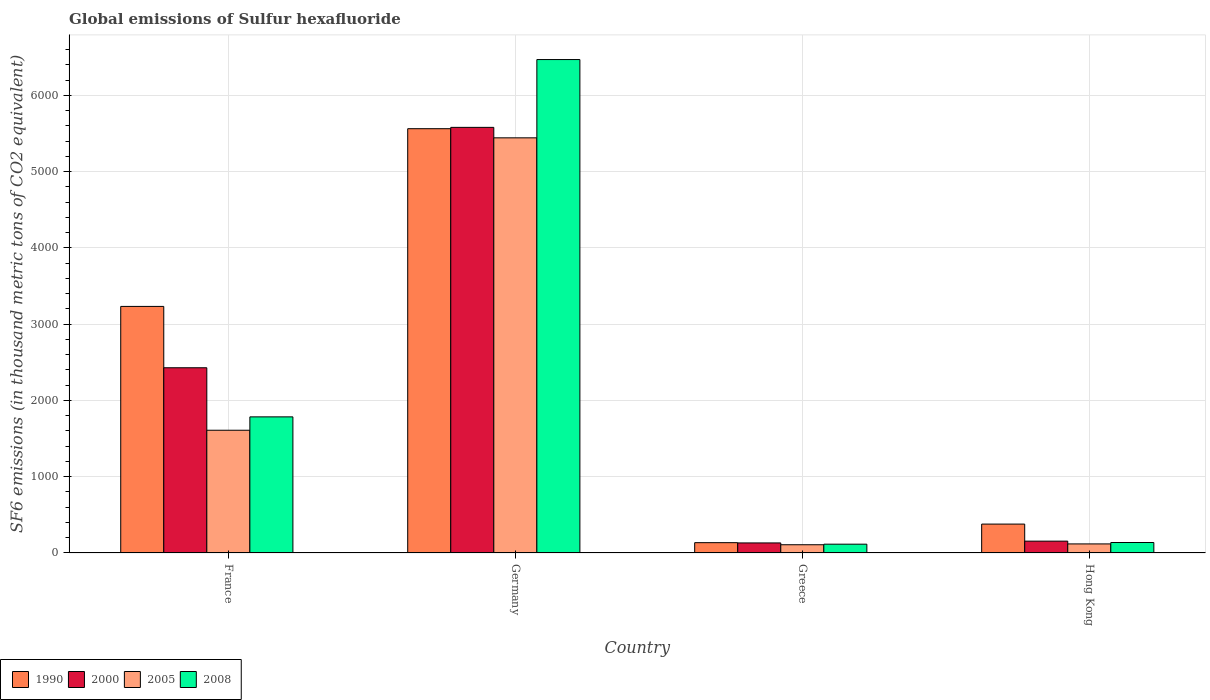How many different coloured bars are there?
Offer a terse response. 4. Are the number of bars per tick equal to the number of legend labels?
Keep it short and to the point. Yes. How many bars are there on the 4th tick from the left?
Provide a succinct answer. 4. How many bars are there on the 1st tick from the right?
Offer a very short reply. 4. In how many cases, is the number of bars for a given country not equal to the number of legend labels?
Provide a short and direct response. 0. What is the global emissions of Sulfur hexafluoride in 1990 in Greece?
Your answer should be very brief. 135.4. Across all countries, what is the maximum global emissions of Sulfur hexafluoride in 2000?
Give a very brief answer. 5580.4. Across all countries, what is the minimum global emissions of Sulfur hexafluoride in 2000?
Offer a very short reply. 131.8. In which country was the global emissions of Sulfur hexafluoride in 2000 minimum?
Offer a very short reply. Greece. What is the total global emissions of Sulfur hexafluoride in 2000 in the graph?
Ensure brevity in your answer.  8296. What is the difference between the global emissions of Sulfur hexafluoride in 2000 in France and that in Greece?
Your answer should be compact. 2296.7. What is the difference between the global emissions of Sulfur hexafluoride in 1990 in France and the global emissions of Sulfur hexafluoride in 2008 in Germany?
Ensure brevity in your answer.  -3236.8. What is the average global emissions of Sulfur hexafluoride in 1990 per country?
Give a very brief answer. 2327.53. What is the difference between the global emissions of Sulfur hexafluoride of/in 2000 and global emissions of Sulfur hexafluoride of/in 2008 in Greece?
Ensure brevity in your answer.  16.4. What is the ratio of the global emissions of Sulfur hexafluoride in 2005 in France to that in Greece?
Ensure brevity in your answer.  14.89. Is the global emissions of Sulfur hexafluoride in 2008 in Germany less than that in Greece?
Make the answer very short. No. What is the difference between the highest and the second highest global emissions of Sulfur hexafluoride in 2000?
Your answer should be very brief. 2273.2. What is the difference between the highest and the lowest global emissions of Sulfur hexafluoride in 1990?
Offer a terse response. 5427.5. Is the sum of the global emissions of Sulfur hexafluoride in 2000 in France and Greece greater than the maximum global emissions of Sulfur hexafluoride in 2005 across all countries?
Your response must be concise. No. What does the 2nd bar from the left in France represents?
Offer a terse response. 2000. What does the 4th bar from the right in Germany represents?
Provide a short and direct response. 1990. How many bars are there?
Make the answer very short. 16. Are all the bars in the graph horizontal?
Keep it short and to the point. No. How are the legend labels stacked?
Give a very brief answer. Horizontal. What is the title of the graph?
Your answer should be very brief. Global emissions of Sulfur hexafluoride. What is the label or title of the X-axis?
Offer a terse response. Country. What is the label or title of the Y-axis?
Keep it short and to the point. SF6 emissions (in thousand metric tons of CO2 equivalent). What is the SF6 emissions (in thousand metric tons of CO2 equivalent) in 1990 in France?
Keep it short and to the point. 3232.8. What is the SF6 emissions (in thousand metric tons of CO2 equivalent) in 2000 in France?
Keep it short and to the point. 2428.5. What is the SF6 emissions (in thousand metric tons of CO2 equivalent) of 2005 in France?
Offer a very short reply. 1609.4. What is the SF6 emissions (in thousand metric tons of CO2 equivalent) in 2008 in France?
Your answer should be compact. 1784.7. What is the SF6 emissions (in thousand metric tons of CO2 equivalent) in 1990 in Germany?
Offer a terse response. 5562.9. What is the SF6 emissions (in thousand metric tons of CO2 equivalent) of 2000 in Germany?
Your answer should be compact. 5580.4. What is the SF6 emissions (in thousand metric tons of CO2 equivalent) in 2005 in Germany?
Your answer should be very brief. 5443.2. What is the SF6 emissions (in thousand metric tons of CO2 equivalent) in 2008 in Germany?
Provide a short and direct response. 6469.6. What is the SF6 emissions (in thousand metric tons of CO2 equivalent) of 1990 in Greece?
Ensure brevity in your answer.  135.4. What is the SF6 emissions (in thousand metric tons of CO2 equivalent) in 2000 in Greece?
Offer a very short reply. 131.8. What is the SF6 emissions (in thousand metric tons of CO2 equivalent) in 2005 in Greece?
Provide a short and direct response. 108.1. What is the SF6 emissions (in thousand metric tons of CO2 equivalent) in 2008 in Greece?
Your answer should be compact. 115.4. What is the SF6 emissions (in thousand metric tons of CO2 equivalent) of 1990 in Hong Kong?
Give a very brief answer. 379. What is the SF6 emissions (in thousand metric tons of CO2 equivalent) in 2000 in Hong Kong?
Provide a succinct answer. 155.3. What is the SF6 emissions (in thousand metric tons of CO2 equivalent) of 2005 in Hong Kong?
Provide a short and direct response. 119. What is the SF6 emissions (in thousand metric tons of CO2 equivalent) of 2008 in Hong Kong?
Provide a succinct answer. 137.4. Across all countries, what is the maximum SF6 emissions (in thousand metric tons of CO2 equivalent) in 1990?
Keep it short and to the point. 5562.9. Across all countries, what is the maximum SF6 emissions (in thousand metric tons of CO2 equivalent) in 2000?
Make the answer very short. 5580.4. Across all countries, what is the maximum SF6 emissions (in thousand metric tons of CO2 equivalent) of 2005?
Make the answer very short. 5443.2. Across all countries, what is the maximum SF6 emissions (in thousand metric tons of CO2 equivalent) of 2008?
Ensure brevity in your answer.  6469.6. Across all countries, what is the minimum SF6 emissions (in thousand metric tons of CO2 equivalent) of 1990?
Offer a terse response. 135.4. Across all countries, what is the minimum SF6 emissions (in thousand metric tons of CO2 equivalent) in 2000?
Offer a very short reply. 131.8. Across all countries, what is the minimum SF6 emissions (in thousand metric tons of CO2 equivalent) in 2005?
Your answer should be very brief. 108.1. Across all countries, what is the minimum SF6 emissions (in thousand metric tons of CO2 equivalent) of 2008?
Offer a terse response. 115.4. What is the total SF6 emissions (in thousand metric tons of CO2 equivalent) of 1990 in the graph?
Offer a very short reply. 9310.1. What is the total SF6 emissions (in thousand metric tons of CO2 equivalent) of 2000 in the graph?
Provide a succinct answer. 8296. What is the total SF6 emissions (in thousand metric tons of CO2 equivalent) in 2005 in the graph?
Ensure brevity in your answer.  7279.7. What is the total SF6 emissions (in thousand metric tons of CO2 equivalent) of 2008 in the graph?
Offer a very short reply. 8507.1. What is the difference between the SF6 emissions (in thousand metric tons of CO2 equivalent) of 1990 in France and that in Germany?
Your response must be concise. -2330.1. What is the difference between the SF6 emissions (in thousand metric tons of CO2 equivalent) in 2000 in France and that in Germany?
Offer a very short reply. -3151.9. What is the difference between the SF6 emissions (in thousand metric tons of CO2 equivalent) of 2005 in France and that in Germany?
Make the answer very short. -3833.8. What is the difference between the SF6 emissions (in thousand metric tons of CO2 equivalent) of 2008 in France and that in Germany?
Your response must be concise. -4684.9. What is the difference between the SF6 emissions (in thousand metric tons of CO2 equivalent) in 1990 in France and that in Greece?
Make the answer very short. 3097.4. What is the difference between the SF6 emissions (in thousand metric tons of CO2 equivalent) of 2000 in France and that in Greece?
Your answer should be compact. 2296.7. What is the difference between the SF6 emissions (in thousand metric tons of CO2 equivalent) of 2005 in France and that in Greece?
Provide a succinct answer. 1501.3. What is the difference between the SF6 emissions (in thousand metric tons of CO2 equivalent) in 2008 in France and that in Greece?
Ensure brevity in your answer.  1669.3. What is the difference between the SF6 emissions (in thousand metric tons of CO2 equivalent) of 1990 in France and that in Hong Kong?
Ensure brevity in your answer.  2853.8. What is the difference between the SF6 emissions (in thousand metric tons of CO2 equivalent) in 2000 in France and that in Hong Kong?
Keep it short and to the point. 2273.2. What is the difference between the SF6 emissions (in thousand metric tons of CO2 equivalent) of 2005 in France and that in Hong Kong?
Your answer should be very brief. 1490.4. What is the difference between the SF6 emissions (in thousand metric tons of CO2 equivalent) of 2008 in France and that in Hong Kong?
Your response must be concise. 1647.3. What is the difference between the SF6 emissions (in thousand metric tons of CO2 equivalent) in 1990 in Germany and that in Greece?
Provide a succinct answer. 5427.5. What is the difference between the SF6 emissions (in thousand metric tons of CO2 equivalent) of 2000 in Germany and that in Greece?
Your response must be concise. 5448.6. What is the difference between the SF6 emissions (in thousand metric tons of CO2 equivalent) of 2005 in Germany and that in Greece?
Your answer should be compact. 5335.1. What is the difference between the SF6 emissions (in thousand metric tons of CO2 equivalent) of 2008 in Germany and that in Greece?
Your answer should be very brief. 6354.2. What is the difference between the SF6 emissions (in thousand metric tons of CO2 equivalent) of 1990 in Germany and that in Hong Kong?
Offer a terse response. 5183.9. What is the difference between the SF6 emissions (in thousand metric tons of CO2 equivalent) in 2000 in Germany and that in Hong Kong?
Ensure brevity in your answer.  5425.1. What is the difference between the SF6 emissions (in thousand metric tons of CO2 equivalent) in 2005 in Germany and that in Hong Kong?
Make the answer very short. 5324.2. What is the difference between the SF6 emissions (in thousand metric tons of CO2 equivalent) of 2008 in Germany and that in Hong Kong?
Offer a very short reply. 6332.2. What is the difference between the SF6 emissions (in thousand metric tons of CO2 equivalent) in 1990 in Greece and that in Hong Kong?
Your response must be concise. -243.6. What is the difference between the SF6 emissions (in thousand metric tons of CO2 equivalent) in 2000 in Greece and that in Hong Kong?
Offer a very short reply. -23.5. What is the difference between the SF6 emissions (in thousand metric tons of CO2 equivalent) of 2005 in Greece and that in Hong Kong?
Your answer should be compact. -10.9. What is the difference between the SF6 emissions (in thousand metric tons of CO2 equivalent) in 1990 in France and the SF6 emissions (in thousand metric tons of CO2 equivalent) in 2000 in Germany?
Your answer should be compact. -2347.6. What is the difference between the SF6 emissions (in thousand metric tons of CO2 equivalent) of 1990 in France and the SF6 emissions (in thousand metric tons of CO2 equivalent) of 2005 in Germany?
Make the answer very short. -2210.4. What is the difference between the SF6 emissions (in thousand metric tons of CO2 equivalent) in 1990 in France and the SF6 emissions (in thousand metric tons of CO2 equivalent) in 2008 in Germany?
Offer a very short reply. -3236.8. What is the difference between the SF6 emissions (in thousand metric tons of CO2 equivalent) of 2000 in France and the SF6 emissions (in thousand metric tons of CO2 equivalent) of 2005 in Germany?
Offer a terse response. -3014.7. What is the difference between the SF6 emissions (in thousand metric tons of CO2 equivalent) in 2000 in France and the SF6 emissions (in thousand metric tons of CO2 equivalent) in 2008 in Germany?
Ensure brevity in your answer.  -4041.1. What is the difference between the SF6 emissions (in thousand metric tons of CO2 equivalent) of 2005 in France and the SF6 emissions (in thousand metric tons of CO2 equivalent) of 2008 in Germany?
Ensure brevity in your answer.  -4860.2. What is the difference between the SF6 emissions (in thousand metric tons of CO2 equivalent) of 1990 in France and the SF6 emissions (in thousand metric tons of CO2 equivalent) of 2000 in Greece?
Offer a terse response. 3101. What is the difference between the SF6 emissions (in thousand metric tons of CO2 equivalent) of 1990 in France and the SF6 emissions (in thousand metric tons of CO2 equivalent) of 2005 in Greece?
Provide a short and direct response. 3124.7. What is the difference between the SF6 emissions (in thousand metric tons of CO2 equivalent) in 1990 in France and the SF6 emissions (in thousand metric tons of CO2 equivalent) in 2008 in Greece?
Ensure brevity in your answer.  3117.4. What is the difference between the SF6 emissions (in thousand metric tons of CO2 equivalent) of 2000 in France and the SF6 emissions (in thousand metric tons of CO2 equivalent) of 2005 in Greece?
Your answer should be very brief. 2320.4. What is the difference between the SF6 emissions (in thousand metric tons of CO2 equivalent) of 2000 in France and the SF6 emissions (in thousand metric tons of CO2 equivalent) of 2008 in Greece?
Your answer should be very brief. 2313.1. What is the difference between the SF6 emissions (in thousand metric tons of CO2 equivalent) of 2005 in France and the SF6 emissions (in thousand metric tons of CO2 equivalent) of 2008 in Greece?
Provide a succinct answer. 1494. What is the difference between the SF6 emissions (in thousand metric tons of CO2 equivalent) in 1990 in France and the SF6 emissions (in thousand metric tons of CO2 equivalent) in 2000 in Hong Kong?
Make the answer very short. 3077.5. What is the difference between the SF6 emissions (in thousand metric tons of CO2 equivalent) of 1990 in France and the SF6 emissions (in thousand metric tons of CO2 equivalent) of 2005 in Hong Kong?
Provide a short and direct response. 3113.8. What is the difference between the SF6 emissions (in thousand metric tons of CO2 equivalent) in 1990 in France and the SF6 emissions (in thousand metric tons of CO2 equivalent) in 2008 in Hong Kong?
Ensure brevity in your answer.  3095.4. What is the difference between the SF6 emissions (in thousand metric tons of CO2 equivalent) in 2000 in France and the SF6 emissions (in thousand metric tons of CO2 equivalent) in 2005 in Hong Kong?
Provide a succinct answer. 2309.5. What is the difference between the SF6 emissions (in thousand metric tons of CO2 equivalent) in 2000 in France and the SF6 emissions (in thousand metric tons of CO2 equivalent) in 2008 in Hong Kong?
Your response must be concise. 2291.1. What is the difference between the SF6 emissions (in thousand metric tons of CO2 equivalent) in 2005 in France and the SF6 emissions (in thousand metric tons of CO2 equivalent) in 2008 in Hong Kong?
Your answer should be very brief. 1472. What is the difference between the SF6 emissions (in thousand metric tons of CO2 equivalent) in 1990 in Germany and the SF6 emissions (in thousand metric tons of CO2 equivalent) in 2000 in Greece?
Your answer should be very brief. 5431.1. What is the difference between the SF6 emissions (in thousand metric tons of CO2 equivalent) in 1990 in Germany and the SF6 emissions (in thousand metric tons of CO2 equivalent) in 2005 in Greece?
Your answer should be compact. 5454.8. What is the difference between the SF6 emissions (in thousand metric tons of CO2 equivalent) of 1990 in Germany and the SF6 emissions (in thousand metric tons of CO2 equivalent) of 2008 in Greece?
Your response must be concise. 5447.5. What is the difference between the SF6 emissions (in thousand metric tons of CO2 equivalent) in 2000 in Germany and the SF6 emissions (in thousand metric tons of CO2 equivalent) in 2005 in Greece?
Offer a very short reply. 5472.3. What is the difference between the SF6 emissions (in thousand metric tons of CO2 equivalent) of 2000 in Germany and the SF6 emissions (in thousand metric tons of CO2 equivalent) of 2008 in Greece?
Ensure brevity in your answer.  5465. What is the difference between the SF6 emissions (in thousand metric tons of CO2 equivalent) in 2005 in Germany and the SF6 emissions (in thousand metric tons of CO2 equivalent) in 2008 in Greece?
Your answer should be compact. 5327.8. What is the difference between the SF6 emissions (in thousand metric tons of CO2 equivalent) in 1990 in Germany and the SF6 emissions (in thousand metric tons of CO2 equivalent) in 2000 in Hong Kong?
Your response must be concise. 5407.6. What is the difference between the SF6 emissions (in thousand metric tons of CO2 equivalent) in 1990 in Germany and the SF6 emissions (in thousand metric tons of CO2 equivalent) in 2005 in Hong Kong?
Provide a short and direct response. 5443.9. What is the difference between the SF6 emissions (in thousand metric tons of CO2 equivalent) in 1990 in Germany and the SF6 emissions (in thousand metric tons of CO2 equivalent) in 2008 in Hong Kong?
Offer a terse response. 5425.5. What is the difference between the SF6 emissions (in thousand metric tons of CO2 equivalent) in 2000 in Germany and the SF6 emissions (in thousand metric tons of CO2 equivalent) in 2005 in Hong Kong?
Keep it short and to the point. 5461.4. What is the difference between the SF6 emissions (in thousand metric tons of CO2 equivalent) in 2000 in Germany and the SF6 emissions (in thousand metric tons of CO2 equivalent) in 2008 in Hong Kong?
Offer a terse response. 5443. What is the difference between the SF6 emissions (in thousand metric tons of CO2 equivalent) of 2005 in Germany and the SF6 emissions (in thousand metric tons of CO2 equivalent) of 2008 in Hong Kong?
Your answer should be compact. 5305.8. What is the difference between the SF6 emissions (in thousand metric tons of CO2 equivalent) in 1990 in Greece and the SF6 emissions (in thousand metric tons of CO2 equivalent) in 2000 in Hong Kong?
Provide a succinct answer. -19.9. What is the difference between the SF6 emissions (in thousand metric tons of CO2 equivalent) in 1990 in Greece and the SF6 emissions (in thousand metric tons of CO2 equivalent) in 2005 in Hong Kong?
Make the answer very short. 16.4. What is the difference between the SF6 emissions (in thousand metric tons of CO2 equivalent) of 1990 in Greece and the SF6 emissions (in thousand metric tons of CO2 equivalent) of 2008 in Hong Kong?
Give a very brief answer. -2. What is the difference between the SF6 emissions (in thousand metric tons of CO2 equivalent) of 2000 in Greece and the SF6 emissions (in thousand metric tons of CO2 equivalent) of 2008 in Hong Kong?
Make the answer very short. -5.6. What is the difference between the SF6 emissions (in thousand metric tons of CO2 equivalent) of 2005 in Greece and the SF6 emissions (in thousand metric tons of CO2 equivalent) of 2008 in Hong Kong?
Your answer should be compact. -29.3. What is the average SF6 emissions (in thousand metric tons of CO2 equivalent) of 1990 per country?
Your response must be concise. 2327.53. What is the average SF6 emissions (in thousand metric tons of CO2 equivalent) in 2000 per country?
Your answer should be compact. 2074. What is the average SF6 emissions (in thousand metric tons of CO2 equivalent) in 2005 per country?
Provide a short and direct response. 1819.92. What is the average SF6 emissions (in thousand metric tons of CO2 equivalent) of 2008 per country?
Provide a short and direct response. 2126.78. What is the difference between the SF6 emissions (in thousand metric tons of CO2 equivalent) in 1990 and SF6 emissions (in thousand metric tons of CO2 equivalent) in 2000 in France?
Provide a succinct answer. 804.3. What is the difference between the SF6 emissions (in thousand metric tons of CO2 equivalent) in 1990 and SF6 emissions (in thousand metric tons of CO2 equivalent) in 2005 in France?
Provide a succinct answer. 1623.4. What is the difference between the SF6 emissions (in thousand metric tons of CO2 equivalent) of 1990 and SF6 emissions (in thousand metric tons of CO2 equivalent) of 2008 in France?
Keep it short and to the point. 1448.1. What is the difference between the SF6 emissions (in thousand metric tons of CO2 equivalent) of 2000 and SF6 emissions (in thousand metric tons of CO2 equivalent) of 2005 in France?
Give a very brief answer. 819.1. What is the difference between the SF6 emissions (in thousand metric tons of CO2 equivalent) in 2000 and SF6 emissions (in thousand metric tons of CO2 equivalent) in 2008 in France?
Ensure brevity in your answer.  643.8. What is the difference between the SF6 emissions (in thousand metric tons of CO2 equivalent) of 2005 and SF6 emissions (in thousand metric tons of CO2 equivalent) of 2008 in France?
Provide a short and direct response. -175.3. What is the difference between the SF6 emissions (in thousand metric tons of CO2 equivalent) of 1990 and SF6 emissions (in thousand metric tons of CO2 equivalent) of 2000 in Germany?
Your response must be concise. -17.5. What is the difference between the SF6 emissions (in thousand metric tons of CO2 equivalent) in 1990 and SF6 emissions (in thousand metric tons of CO2 equivalent) in 2005 in Germany?
Give a very brief answer. 119.7. What is the difference between the SF6 emissions (in thousand metric tons of CO2 equivalent) in 1990 and SF6 emissions (in thousand metric tons of CO2 equivalent) in 2008 in Germany?
Ensure brevity in your answer.  -906.7. What is the difference between the SF6 emissions (in thousand metric tons of CO2 equivalent) of 2000 and SF6 emissions (in thousand metric tons of CO2 equivalent) of 2005 in Germany?
Your response must be concise. 137.2. What is the difference between the SF6 emissions (in thousand metric tons of CO2 equivalent) of 2000 and SF6 emissions (in thousand metric tons of CO2 equivalent) of 2008 in Germany?
Offer a very short reply. -889.2. What is the difference between the SF6 emissions (in thousand metric tons of CO2 equivalent) in 2005 and SF6 emissions (in thousand metric tons of CO2 equivalent) in 2008 in Germany?
Provide a short and direct response. -1026.4. What is the difference between the SF6 emissions (in thousand metric tons of CO2 equivalent) in 1990 and SF6 emissions (in thousand metric tons of CO2 equivalent) in 2005 in Greece?
Offer a very short reply. 27.3. What is the difference between the SF6 emissions (in thousand metric tons of CO2 equivalent) of 2000 and SF6 emissions (in thousand metric tons of CO2 equivalent) of 2005 in Greece?
Offer a very short reply. 23.7. What is the difference between the SF6 emissions (in thousand metric tons of CO2 equivalent) of 2000 and SF6 emissions (in thousand metric tons of CO2 equivalent) of 2008 in Greece?
Your answer should be very brief. 16.4. What is the difference between the SF6 emissions (in thousand metric tons of CO2 equivalent) of 2005 and SF6 emissions (in thousand metric tons of CO2 equivalent) of 2008 in Greece?
Provide a short and direct response. -7.3. What is the difference between the SF6 emissions (in thousand metric tons of CO2 equivalent) of 1990 and SF6 emissions (in thousand metric tons of CO2 equivalent) of 2000 in Hong Kong?
Make the answer very short. 223.7. What is the difference between the SF6 emissions (in thousand metric tons of CO2 equivalent) in 1990 and SF6 emissions (in thousand metric tons of CO2 equivalent) in 2005 in Hong Kong?
Make the answer very short. 260. What is the difference between the SF6 emissions (in thousand metric tons of CO2 equivalent) of 1990 and SF6 emissions (in thousand metric tons of CO2 equivalent) of 2008 in Hong Kong?
Provide a short and direct response. 241.6. What is the difference between the SF6 emissions (in thousand metric tons of CO2 equivalent) in 2000 and SF6 emissions (in thousand metric tons of CO2 equivalent) in 2005 in Hong Kong?
Your response must be concise. 36.3. What is the difference between the SF6 emissions (in thousand metric tons of CO2 equivalent) of 2005 and SF6 emissions (in thousand metric tons of CO2 equivalent) of 2008 in Hong Kong?
Give a very brief answer. -18.4. What is the ratio of the SF6 emissions (in thousand metric tons of CO2 equivalent) in 1990 in France to that in Germany?
Provide a short and direct response. 0.58. What is the ratio of the SF6 emissions (in thousand metric tons of CO2 equivalent) in 2000 in France to that in Germany?
Your answer should be very brief. 0.44. What is the ratio of the SF6 emissions (in thousand metric tons of CO2 equivalent) in 2005 in France to that in Germany?
Your answer should be very brief. 0.3. What is the ratio of the SF6 emissions (in thousand metric tons of CO2 equivalent) of 2008 in France to that in Germany?
Your response must be concise. 0.28. What is the ratio of the SF6 emissions (in thousand metric tons of CO2 equivalent) in 1990 in France to that in Greece?
Offer a terse response. 23.88. What is the ratio of the SF6 emissions (in thousand metric tons of CO2 equivalent) in 2000 in France to that in Greece?
Ensure brevity in your answer.  18.43. What is the ratio of the SF6 emissions (in thousand metric tons of CO2 equivalent) of 2005 in France to that in Greece?
Keep it short and to the point. 14.89. What is the ratio of the SF6 emissions (in thousand metric tons of CO2 equivalent) of 2008 in France to that in Greece?
Your answer should be compact. 15.47. What is the ratio of the SF6 emissions (in thousand metric tons of CO2 equivalent) of 1990 in France to that in Hong Kong?
Your answer should be very brief. 8.53. What is the ratio of the SF6 emissions (in thousand metric tons of CO2 equivalent) of 2000 in France to that in Hong Kong?
Give a very brief answer. 15.64. What is the ratio of the SF6 emissions (in thousand metric tons of CO2 equivalent) of 2005 in France to that in Hong Kong?
Offer a very short reply. 13.52. What is the ratio of the SF6 emissions (in thousand metric tons of CO2 equivalent) in 2008 in France to that in Hong Kong?
Offer a terse response. 12.99. What is the ratio of the SF6 emissions (in thousand metric tons of CO2 equivalent) of 1990 in Germany to that in Greece?
Make the answer very short. 41.08. What is the ratio of the SF6 emissions (in thousand metric tons of CO2 equivalent) in 2000 in Germany to that in Greece?
Your answer should be very brief. 42.34. What is the ratio of the SF6 emissions (in thousand metric tons of CO2 equivalent) in 2005 in Germany to that in Greece?
Your answer should be very brief. 50.35. What is the ratio of the SF6 emissions (in thousand metric tons of CO2 equivalent) of 2008 in Germany to that in Greece?
Keep it short and to the point. 56.06. What is the ratio of the SF6 emissions (in thousand metric tons of CO2 equivalent) in 1990 in Germany to that in Hong Kong?
Offer a terse response. 14.68. What is the ratio of the SF6 emissions (in thousand metric tons of CO2 equivalent) of 2000 in Germany to that in Hong Kong?
Keep it short and to the point. 35.93. What is the ratio of the SF6 emissions (in thousand metric tons of CO2 equivalent) of 2005 in Germany to that in Hong Kong?
Keep it short and to the point. 45.74. What is the ratio of the SF6 emissions (in thousand metric tons of CO2 equivalent) in 2008 in Germany to that in Hong Kong?
Your answer should be very brief. 47.09. What is the ratio of the SF6 emissions (in thousand metric tons of CO2 equivalent) of 1990 in Greece to that in Hong Kong?
Your answer should be very brief. 0.36. What is the ratio of the SF6 emissions (in thousand metric tons of CO2 equivalent) of 2000 in Greece to that in Hong Kong?
Provide a short and direct response. 0.85. What is the ratio of the SF6 emissions (in thousand metric tons of CO2 equivalent) in 2005 in Greece to that in Hong Kong?
Your answer should be compact. 0.91. What is the ratio of the SF6 emissions (in thousand metric tons of CO2 equivalent) of 2008 in Greece to that in Hong Kong?
Keep it short and to the point. 0.84. What is the difference between the highest and the second highest SF6 emissions (in thousand metric tons of CO2 equivalent) of 1990?
Ensure brevity in your answer.  2330.1. What is the difference between the highest and the second highest SF6 emissions (in thousand metric tons of CO2 equivalent) in 2000?
Keep it short and to the point. 3151.9. What is the difference between the highest and the second highest SF6 emissions (in thousand metric tons of CO2 equivalent) in 2005?
Ensure brevity in your answer.  3833.8. What is the difference between the highest and the second highest SF6 emissions (in thousand metric tons of CO2 equivalent) of 2008?
Keep it short and to the point. 4684.9. What is the difference between the highest and the lowest SF6 emissions (in thousand metric tons of CO2 equivalent) of 1990?
Keep it short and to the point. 5427.5. What is the difference between the highest and the lowest SF6 emissions (in thousand metric tons of CO2 equivalent) in 2000?
Offer a very short reply. 5448.6. What is the difference between the highest and the lowest SF6 emissions (in thousand metric tons of CO2 equivalent) in 2005?
Provide a short and direct response. 5335.1. What is the difference between the highest and the lowest SF6 emissions (in thousand metric tons of CO2 equivalent) of 2008?
Provide a succinct answer. 6354.2. 